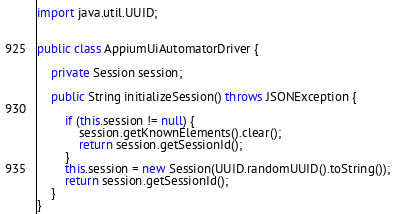<code> <loc_0><loc_0><loc_500><loc_500><_Java_>import java.util.UUID;


public class AppiumUiAutomatorDriver {

    private Session session;

    public String initializeSession() throws JSONException {

        if (this.session != null) {
            session.getKnownElements().clear();
            return session.getSessionId();
        }
        this.session = new Session(UUID.randomUUID().toString());
        return session.getSessionId();
    }
}

</code> 